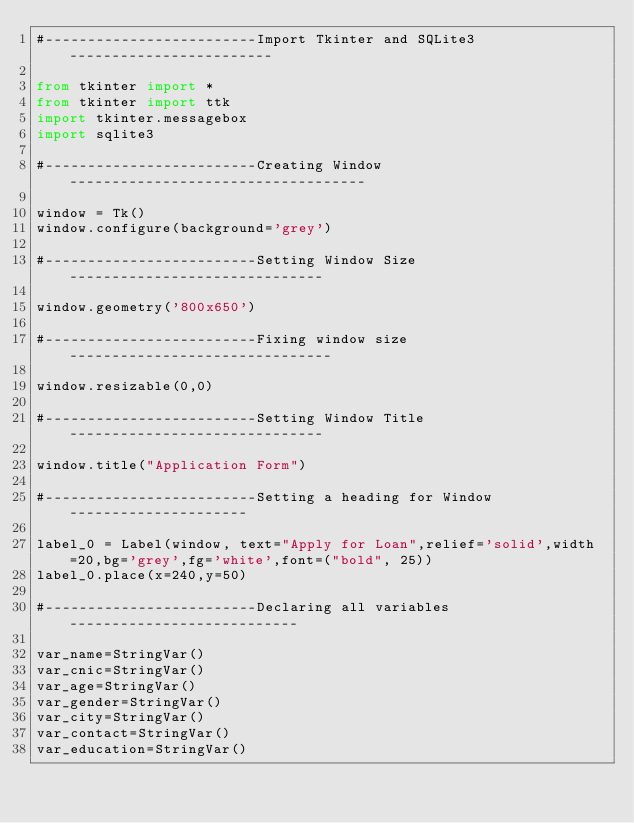<code> <loc_0><loc_0><loc_500><loc_500><_Python_>#-------------------------Import Tkinter and SQLite3------------------------

from tkinter import *
from tkinter import ttk
import tkinter.messagebox
import sqlite3

#-------------------------Creating Window-----------------------------------

window = Tk()
window.configure(background='grey')

#-------------------------Setting Window Size------------------------------

window.geometry('800x650')

#-------------------------Fixing window size-------------------------------

window.resizable(0,0)

#-------------------------Setting Window Title------------------------------

window.title("Application Form")

#-------------------------Setting a heading for Window---------------------

label_0 = Label(window, text="Apply for Loan",relief='solid',width=20,bg='grey',fg='white',font=("bold", 25))
label_0.place(x=240,y=50)

#-------------------------Declaring all variables---------------------------

var_name=StringVar()
var_cnic=StringVar()
var_age=StringVar()
var_gender=StringVar()
var_city=StringVar()
var_contact=StringVar()
var_education=StringVar()</code> 